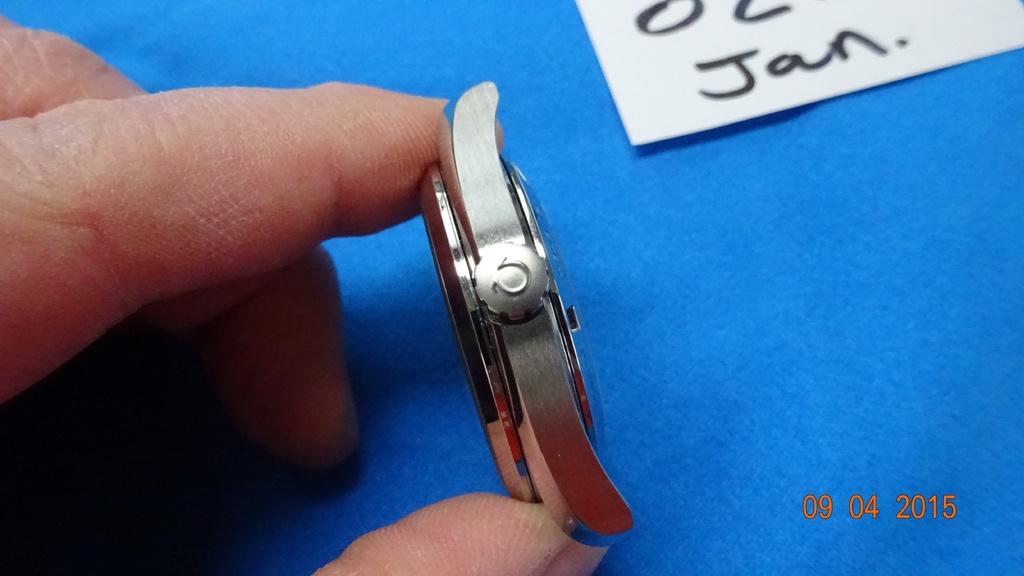What is the date on the bottom right corner?
Offer a terse response. 09 04 2015. What month can be seen abbreviated to the very top right?
Your response must be concise. January. 